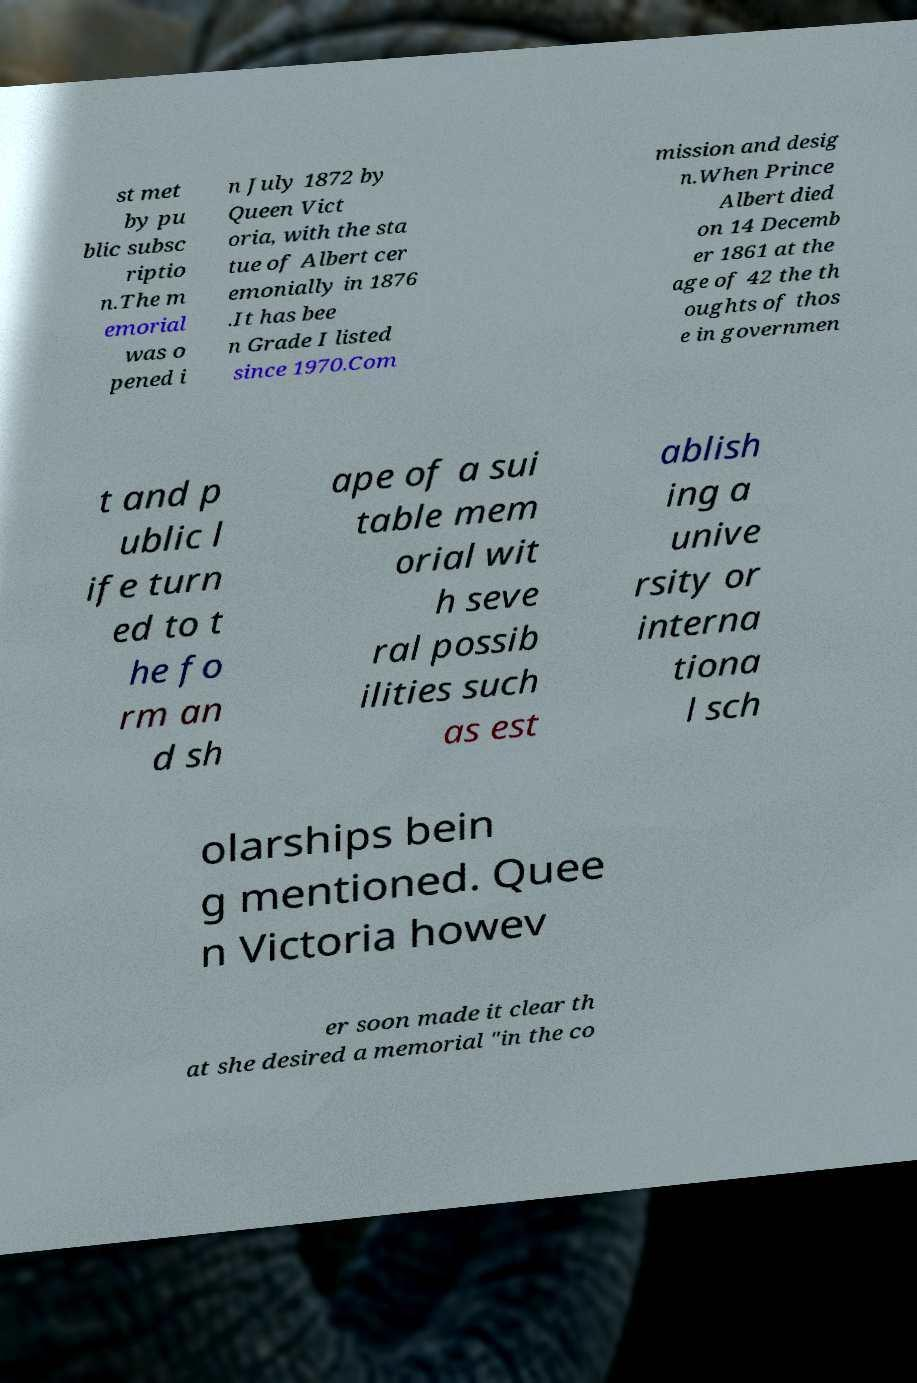Can you read and provide the text displayed in the image?This photo seems to have some interesting text. Can you extract and type it out for me? st met by pu blic subsc riptio n.The m emorial was o pened i n July 1872 by Queen Vict oria, with the sta tue of Albert cer emonially in 1876 .It has bee n Grade I listed since 1970.Com mission and desig n.When Prince Albert died on 14 Decemb er 1861 at the age of 42 the th oughts of thos e in governmen t and p ublic l ife turn ed to t he fo rm an d sh ape of a sui table mem orial wit h seve ral possib ilities such as est ablish ing a unive rsity or interna tiona l sch olarships bein g mentioned. Quee n Victoria howev er soon made it clear th at she desired a memorial "in the co 